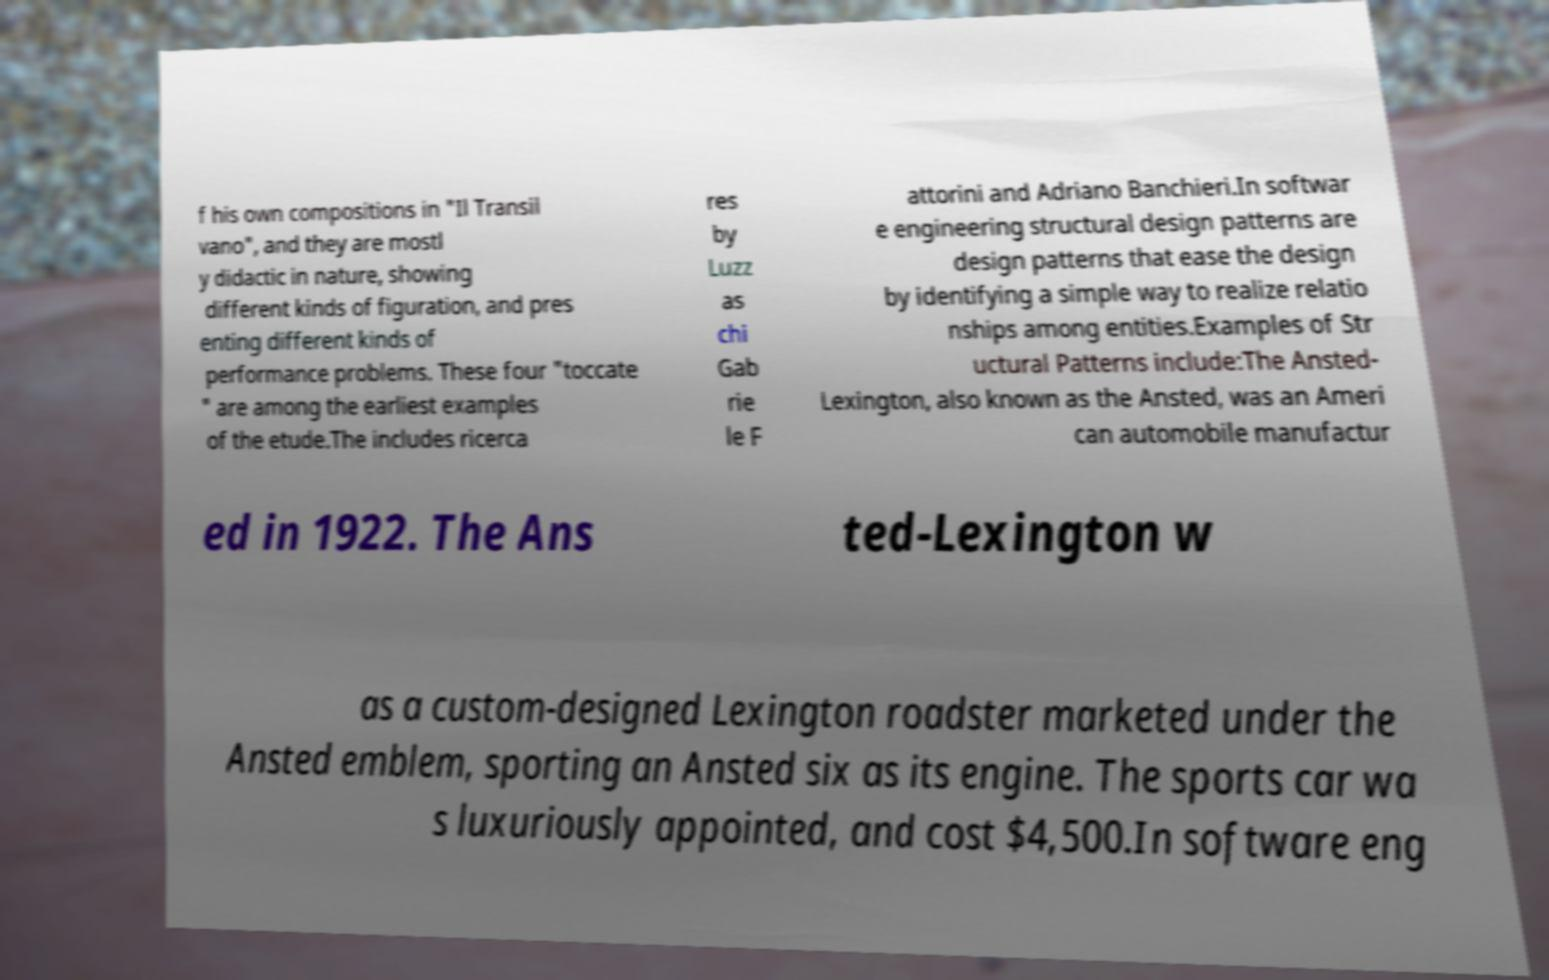Could you assist in decoding the text presented in this image and type it out clearly? f his own compositions in "Il Transil vano", and they are mostl y didactic in nature, showing different kinds of figuration, and pres enting different kinds of performance problems. These four "toccate " are among the earliest examples of the etude.The includes ricerca res by Luzz as chi Gab rie le F attorini and Adriano Banchieri.In softwar e engineering structural design patterns are design patterns that ease the design by identifying a simple way to realize relatio nships among entities.Examples of Str uctural Patterns include:The Ansted- Lexington, also known as the Ansted, was an Ameri can automobile manufactur ed in 1922. The Ans ted-Lexington w as a custom-designed Lexington roadster marketed under the Ansted emblem, sporting an Ansted six as its engine. The sports car wa s luxuriously appointed, and cost $4,500.In software eng 